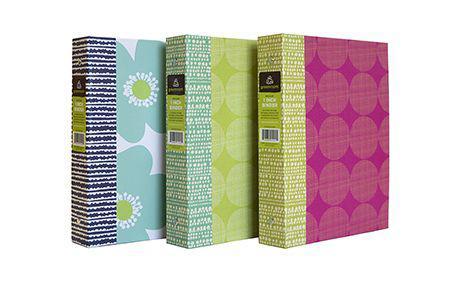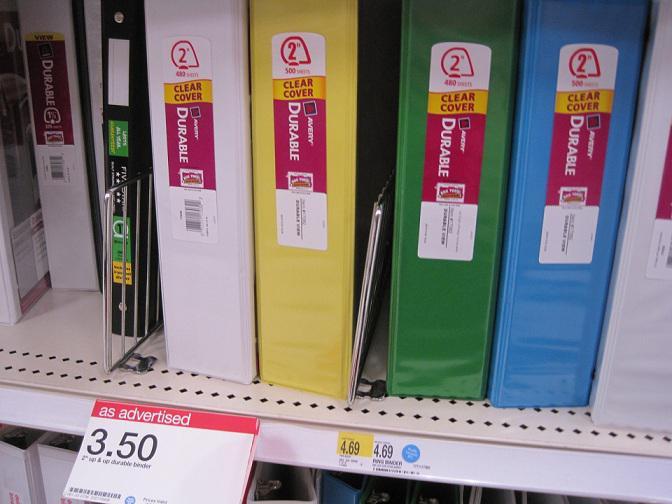The first image is the image on the left, the second image is the image on the right. Analyze the images presented: Is the assertion "At least one of the binders is open." valid? Answer yes or no. No. The first image is the image on the left, the second image is the image on the right. Considering the images on both sides, is "One binder is open and showing its prongs." valid? Answer yes or no. No. 